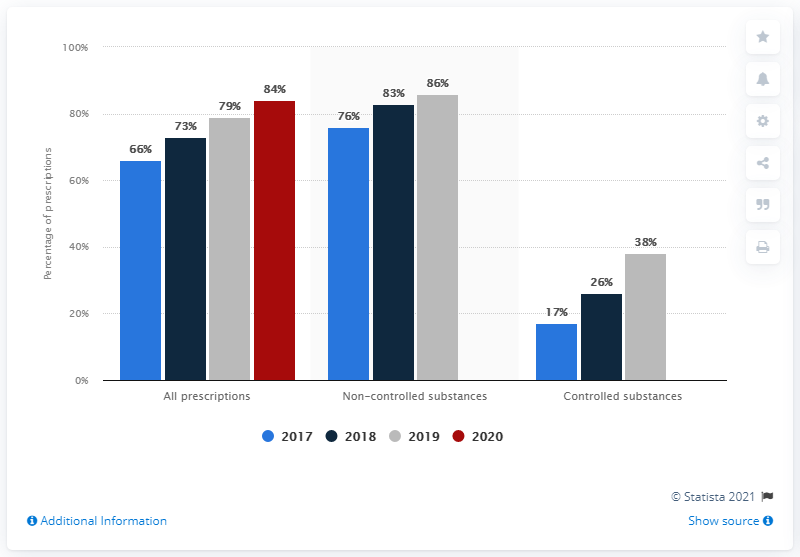Give some essential details in this illustration. The total percentage of prescriptions for controlled substances in 2019 was 38%. The average percentage of prescriptions of controlled substances from 2018 to 2019 was 32%. 